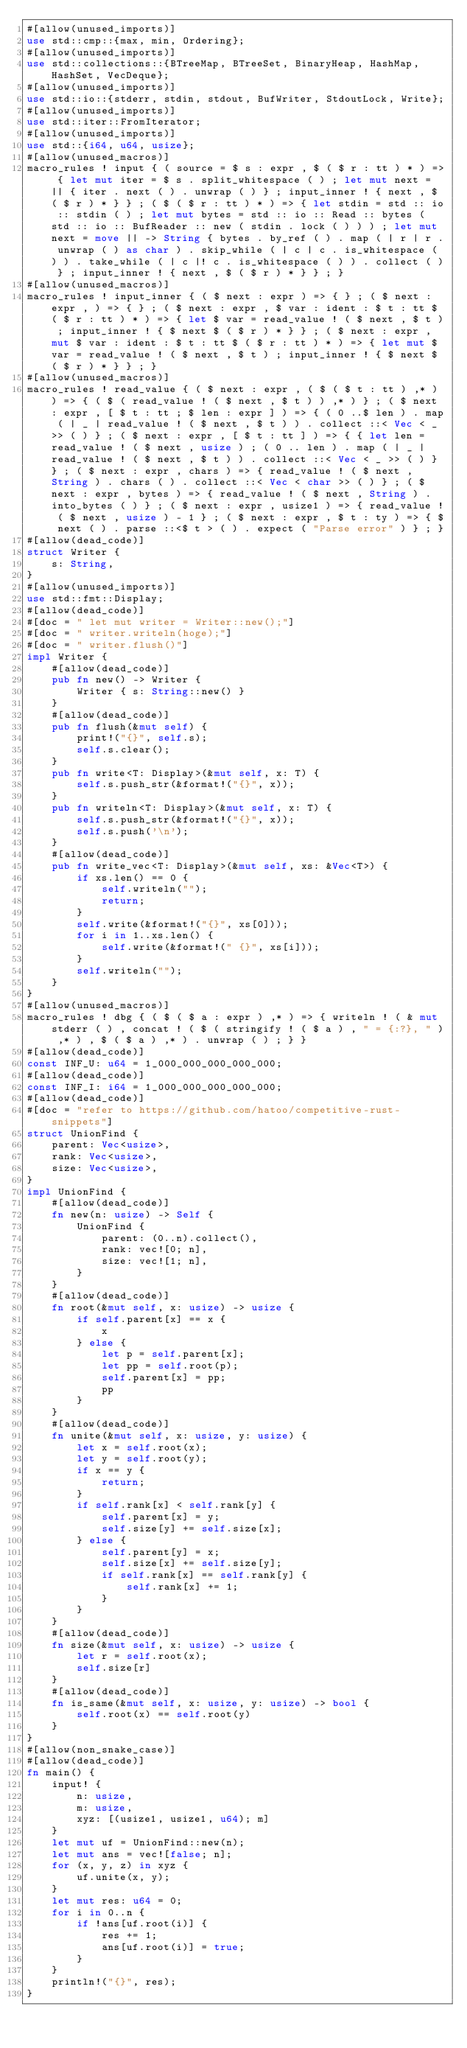<code> <loc_0><loc_0><loc_500><loc_500><_Rust_>#[allow(unused_imports)]
use std::cmp::{max, min, Ordering};
#[allow(unused_imports)]
use std::collections::{BTreeMap, BTreeSet, BinaryHeap, HashMap, HashSet, VecDeque};
#[allow(unused_imports)]
use std::io::{stderr, stdin, stdout, BufWriter, StdoutLock, Write};
#[allow(unused_imports)]
use std::iter::FromIterator;
#[allow(unused_imports)]
use std::{i64, u64, usize};
#[allow(unused_macros)]
macro_rules ! input { ( source = $ s : expr , $ ( $ r : tt ) * ) => { let mut iter = $ s . split_whitespace ( ) ; let mut next = || { iter . next ( ) . unwrap ( ) } ; input_inner ! { next , $ ( $ r ) * } } ; ( $ ( $ r : tt ) * ) => { let stdin = std :: io :: stdin ( ) ; let mut bytes = std :: io :: Read :: bytes ( std :: io :: BufReader :: new ( stdin . lock ( ) ) ) ; let mut next = move || -> String { bytes . by_ref ( ) . map ( | r | r . unwrap ( ) as char ) . skip_while ( | c | c . is_whitespace ( ) ) . take_while ( | c |! c . is_whitespace ( ) ) . collect ( ) } ; input_inner ! { next , $ ( $ r ) * } } ; }
#[allow(unused_macros)]
macro_rules ! input_inner { ( $ next : expr ) => { } ; ( $ next : expr , ) => { } ; ( $ next : expr , $ var : ident : $ t : tt $ ( $ r : tt ) * ) => { let $ var = read_value ! ( $ next , $ t ) ; input_inner ! { $ next $ ( $ r ) * } } ; ( $ next : expr , mut $ var : ident : $ t : tt $ ( $ r : tt ) * ) => { let mut $ var = read_value ! ( $ next , $ t ) ; input_inner ! { $ next $ ( $ r ) * } } ; }
#[allow(unused_macros)]
macro_rules ! read_value { ( $ next : expr , ( $ ( $ t : tt ) ,* ) ) => { ( $ ( read_value ! ( $ next , $ t ) ) ,* ) } ; ( $ next : expr , [ $ t : tt ; $ len : expr ] ) => { ( 0 ..$ len ) . map ( | _ | read_value ! ( $ next , $ t ) ) . collect ::< Vec < _ >> ( ) } ; ( $ next : expr , [ $ t : tt ] ) => { { let len = read_value ! ( $ next , usize ) ; ( 0 .. len ) . map ( | _ | read_value ! ( $ next , $ t ) ) . collect ::< Vec < _ >> ( ) } } ; ( $ next : expr , chars ) => { read_value ! ( $ next , String ) . chars ( ) . collect ::< Vec < char >> ( ) } ; ( $ next : expr , bytes ) => { read_value ! ( $ next , String ) . into_bytes ( ) } ; ( $ next : expr , usize1 ) => { read_value ! ( $ next , usize ) - 1 } ; ( $ next : expr , $ t : ty ) => { $ next ( ) . parse ::<$ t > ( ) . expect ( "Parse error" ) } ; }
#[allow(dead_code)]
struct Writer {
    s: String,
}
#[allow(unused_imports)]
use std::fmt::Display;
#[allow(dead_code)]
#[doc = " let mut writer = Writer::new();"]
#[doc = " writer.writeln(hoge);"]
#[doc = " writer.flush()"]
impl Writer {
    #[allow(dead_code)]
    pub fn new() -> Writer {
        Writer { s: String::new() }
    }
    #[allow(dead_code)]
    pub fn flush(&mut self) {
        print!("{}", self.s);
        self.s.clear();
    }
    pub fn write<T: Display>(&mut self, x: T) {
        self.s.push_str(&format!("{}", x));
    }
    pub fn writeln<T: Display>(&mut self, x: T) {
        self.s.push_str(&format!("{}", x));
        self.s.push('\n');
    }
    #[allow(dead_code)]
    pub fn write_vec<T: Display>(&mut self, xs: &Vec<T>) {
        if xs.len() == 0 {
            self.writeln("");
            return;
        }
        self.write(&format!("{}", xs[0]));
        for i in 1..xs.len() {
            self.write(&format!(" {}", xs[i]));
        }
        self.writeln("");
    }
}
#[allow(unused_macros)]
macro_rules ! dbg { ( $ ( $ a : expr ) ,* ) => { writeln ! ( & mut stderr ( ) , concat ! ( $ ( stringify ! ( $ a ) , " = {:?}, " ) ,* ) , $ ( $ a ) ,* ) . unwrap ( ) ; } }
#[allow(dead_code)]
const INF_U: u64 = 1_000_000_000_000_000;
#[allow(dead_code)]
const INF_I: i64 = 1_000_000_000_000_000;
#[allow(dead_code)]
#[doc = "refer to https://github.com/hatoo/competitive-rust-snippets"]
struct UnionFind {
    parent: Vec<usize>,
    rank: Vec<usize>,
    size: Vec<usize>,
}
impl UnionFind {
    #[allow(dead_code)]
    fn new(n: usize) -> Self {
        UnionFind {
            parent: (0..n).collect(),
            rank: vec![0; n],
            size: vec![1; n],
        }
    }
    #[allow(dead_code)]
    fn root(&mut self, x: usize) -> usize {
        if self.parent[x] == x {
            x
        } else {
            let p = self.parent[x];
            let pp = self.root(p);
            self.parent[x] = pp;
            pp
        }
    }
    #[allow(dead_code)]
    fn unite(&mut self, x: usize, y: usize) {
        let x = self.root(x);
        let y = self.root(y);
        if x == y {
            return;
        }
        if self.rank[x] < self.rank[y] {
            self.parent[x] = y;
            self.size[y] += self.size[x];
        } else {
            self.parent[y] = x;
            self.size[x] += self.size[y];
            if self.rank[x] == self.rank[y] {
                self.rank[x] += 1;
            }
        }
    }
    #[allow(dead_code)]
    fn size(&mut self, x: usize) -> usize {
        let r = self.root(x);
        self.size[r]
    }
    #[allow(dead_code)]
    fn is_same(&mut self, x: usize, y: usize) -> bool {
        self.root(x) == self.root(y)
    }
}
#[allow(non_snake_case)]
#[allow(dead_code)]
fn main() {
    input! {
        n: usize,
        m: usize,
        xyz: [(usize1, usize1, u64); m]
    }
    let mut uf = UnionFind::new(n);
    let mut ans = vec![false; n];
    for (x, y, z) in xyz {
        uf.unite(x, y);
    }
    let mut res: u64 = 0;
    for i in 0..n {
        if !ans[uf.root(i)] {
            res += 1;
            ans[uf.root(i)] = true;
        }
    }
    println!("{}", res);
}</code> 